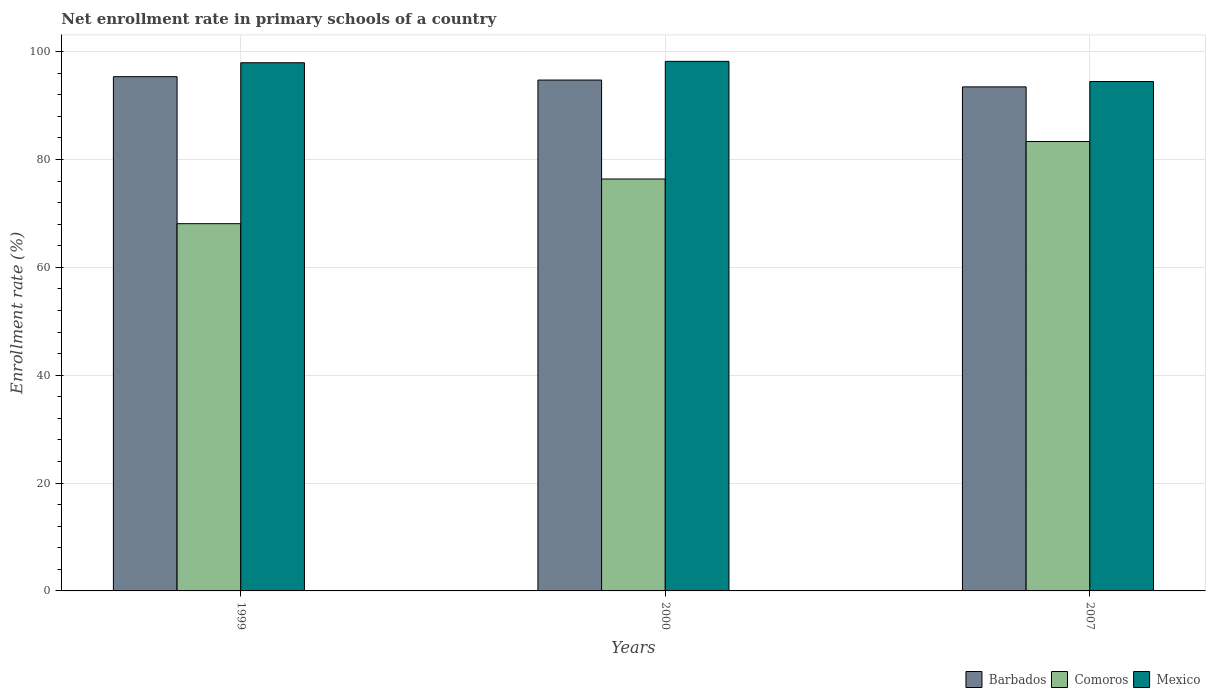How many bars are there on the 1st tick from the left?
Ensure brevity in your answer.  3. How many bars are there on the 3rd tick from the right?
Offer a very short reply. 3. In how many cases, is the number of bars for a given year not equal to the number of legend labels?
Your answer should be very brief. 0. What is the enrollment rate in primary schools in Mexico in 2000?
Ensure brevity in your answer.  98.2. Across all years, what is the maximum enrollment rate in primary schools in Mexico?
Keep it short and to the point. 98.2. Across all years, what is the minimum enrollment rate in primary schools in Barbados?
Your answer should be very brief. 93.47. What is the total enrollment rate in primary schools in Comoros in the graph?
Provide a succinct answer. 227.81. What is the difference between the enrollment rate in primary schools in Mexico in 1999 and that in 2007?
Provide a short and direct response. 3.48. What is the difference between the enrollment rate in primary schools in Comoros in 2007 and the enrollment rate in primary schools in Barbados in 1999?
Offer a terse response. -12.03. What is the average enrollment rate in primary schools in Barbados per year?
Keep it short and to the point. 94.52. In the year 2000, what is the difference between the enrollment rate in primary schools in Barbados and enrollment rate in primary schools in Mexico?
Provide a short and direct response. -3.47. What is the ratio of the enrollment rate in primary schools in Mexico in 1999 to that in 2007?
Your answer should be very brief. 1.04. Is the enrollment rate in primary schools in Barbados in 1999 less than that in 2007?
Your response must be concise. No. Is the difference between the enrollment rate in primary schools in Barbados in 2000 and 2007 greater than the difference between the enrollment rate in primary schools in Mexico in 2000 and 2007?
Provide a succinct answer. No. What is the difference between the highest and the second highest enrollment rate in primary schools in Mexico?
Keep it short and to the point. 0.26. What is the difference between the highest and the lowest enrollment rate in primary schools in Mexico?
Your response must be concise. 3.74. In how many years, is the enrollment rate in primary schools in Comoros greater than the average enrollment rate in primary schools in Comoros taken over all years?
Make the answer very short. 2. Is the sum of the enrollment rate in primary schools in Comoros in 1999 and 2000 greater than the maximum enrollment rate in primary schools in Barbados across all years?
Ensure brevity in your answer.  Yes. What does the 3rd bar from the right in 2000 represents?
Offer a terse response. Barbados. How many bars are there?
Offer a very short reply. 9. Are all the bars in the graph horizontal?
Provide a short and direct response. No. Does the graph contain any zero values?
Offer a terse response. No. How many legend labels are there?
Your answer should be very brief. 3. How are the legend labels stacked?
Provide a succinct answer. Horizontal. What is the title of the graph?
Make the answer very short. Net enrollment rate in primary schools of a country. What is the label or title of the X-axis?
Provide a short and direct response. Years. What is the label or title of the Y-axis?
Provide a succinct answer. Enrollment rate (%). What is the Enrollment rate (%) in Barbados in 1999?
Give a very brief answer. 95.36. What is the Enrollment rate (%) in Comoros in 1999?
Ensure brevity in your answer.  68.1. What is the Enrollment rate (%) in Mexico in 1999?
Your answer should be compact. 97.94. What is the Enrollment rate (%) in Barbados in 2000?
Offer a very short reply. 94.73. What is the Enrollment rate (%) in Comoros in 2000?
Provide a short and direct response. 76.38. What is the Enrollment rate (%) of Mexico in 2000?
Provide a succinct answer. 98.2. What is the Enrollment rate (%) of Barbados in 2007?
Ensure brevity in your answer.  93.47. What is the Enrollment rate (%) in Comoros in 2007?
Your answer should be very brief. 83.33. What is the Enrollment rate (%) of Mexico in 2007?
Provide a short and direct response. 94.46. Across all years, what is the maximum Enrollment rate (%) of Barbados?
Ensure brevity in your answer.  95.36. Across all years, what is the maximum Enrollment rate (%) in Comoros?
Keep it short and to the point. 83.33. Across all years, what is the maximum Enrollment rate (%) of Mexico?
Your response must be concise. 98.2. Across all years, what is the minimum Enrollment rate (%) of Barbados?
Offer a terse response. 93.47. Across all years, what is the minimum Enrollment rate (%) of Comoros?
Your answer should be compact. 68.1. Across all years, what is the minimum Enrollment rate (%) in Mexico?
Keep it short and to the point. 94.46. What is the total Enrollment rate (%) in Barbados in the graph?
Your answer should be compact. 283.56. What is the total Enrollment rate (%) in Comoros in the graph?
Ensure brevity in your answer.  227.81. What is the total Enrollment rate (%) in Mexico in the graph?
Give a very brief answer. 290.6. What is the difference between the Enrollment rate (%) in Barbados in 1999 and that in 2000?
Provide a succinct answer. 0.63. What is the difference between the Enrollment rate (%) in Comoros in 1999 and that in 2000?
Your answer should be compact. -8.28. What is the difference between the Enrollment rate (%) of Mexico in 1999 and that in 2000?
Offer a very short reply. -0.26. What is the difference between the Enrollment rate (%) of Barbados in 1999 and that in 2007?
Offer a very short reply. 1.89. What is the difference between the Enrollment rate (%) in Comoros in 1999 and that in 2007?
Provide a short and direct response. -15.23. What is the difference between the Enrollment rate (%) in Mexico in 1999 and that in 2007?
Ensure brevity in your answer.  3.48. What is the difference between the Enrollment rate (%) in Barbados in 2000 and that in 2007?
Offer a very short reply. 1.27. What is the difference between the Enrollment rate (%) of Comoros in 2000 and that in 2007?
Your answer should be very brief. -6.95. What is the difference between the Enrollment rate (%) of Mexico in 2000 and that in 2007?
Your answer should be very brief. 3.74. What is the difference between the Enrollment rate (%) of Barbados in 1999 and the Enrollment rate (%) of Comoros in 2000?
Offer a terse response. 18.98. What is the difference between the Enrollment rate (%) of Barbados in 1999 and the Enrollment rate (%) of Mexico in 2000?
Offer a very short reply. -2.84. What is the difference between the Enrollment rate (%) of Comoros in 1999 and the Enrollment rate (%) of Mexico in 2000?
Your answer should be compact. -30.1. What is the difference between the Enrollment rate (%) in Barbados in 1999 and the Enrollment rate (%) in Comoros in 2007?
Your answer should be very brief. 12.03. What is the difference between the Enrollment rate (%) of Barbados in 1999 and the Enrollment rate (%) of Mexico in 2007?
Provide a succinct answer. 0.9. What is the difference between the Enrollment rate (%) of Comoros in 1999 and the Enrollment rate (%) of Mexico in 2007?
Make the answer very short. -26.36. What is the difference between the Enrollment rate (%) of Barbados in 2000 and the Enrollment rate (%) of Comoros in 2007?
Offer a terse response. 11.4. What is the difference between the Enrollment rate (%) in Barbados in 2000 and the Enrollment rate (%) in Mexico in 2007?
Ensure brevity in your answer.  0.27. What is the difference between the Enrollment rate (%) in Comoros in 2000 and the Enrollment rate (%) in Mexico in 2007?
Make the answer very short. -18.08. What is the average Enrollment rate (%) of Barbados per year?
Offer a very short reply. 94.52. What is the average Enrollment rate (%) of Comoros per year?
Offer a very short reply. 75.94. What is the average Enrollment rate (%) of Mexico per year?
Keep it short and to the point. 96.87. In the year 1999, what is the difference between the Enrollment rate (%) in Barbados and Enrollment rate (%) in Comoros?
Offer a terse response. 27.26. In the year 1999, what is the difference between the Enrollment rate (%) in Barbados and Enrollment rate (%) in Mexico?
Your response must be concise. -2.58. In the year 1999, what is the difference between the Enrollment rate (%) in Comoros and Enrollment rate (%) in Mexico?
Keep it short and to the point. -29.84. In the year 2000, what is the difference between the Enrollment rate (%) in Barbados and Enrollment rate (%) in Comoros?
Provide a short and direct response. 18.35. In the year 2000, what is the difference between the Enrollment rate (%) in Barbados and Enrollment rate (%) in Mexico?
Keep it short and to the point. -3.47. In the year 2000, what is the difference between the Enrollment rate (%) in Comoros and Enrollment rate (%) in Mexico?
Offer a very short reply. -21.82. In the year 2007, what is the difference between the Enrollment rate (%) in Barbados and Enrollment rate (%) in Comoros?
Give a very brief answer. 10.13. In the year 2007, what is the difference between the Enrollment rate (%) in Barbados and Enrollment rate (%) in Mexico?
Provide a succinct answer. -0.99. In the year 2007, what is the difference between the Enrollment rate (%) of Comoros and Enrollment rate (%) of Mexico?
Your answer should be very brief. -11.13. What is the ratio of the Enrollment rate (%) of Barbados in 1999 to that in 2000?
Offer a terse response. 1.01. What is the ratio of the Enrollment rate (%) in Comoros in 1999 to that in 2000?
Ensure brevity in your answer.  0.89. What is the ratio of the Enrollment rate (%) of Mexico in 1999 to that in 2000?
Provide a short and direct response. 1. What is the ratio of the Enrollment rate (%) of Barbados in 1999 to that in 2007?
Ensure brevity in your answer.  1.02. What is the ratio of the Enrollment rate (%) in Comoros in 1999 to that in 2007?
Offer a very short reply. 0.82. What is the ratio of the Enrollment rate (%) of Mexico in 1999 to that in 2007?
Your response must be concise. 1.04. What is the ratio of the Enrollment rate (%) in Barbados in 2000 to that in 2007?
Provide a succinct answer. 1.01. What is the ratio of the Enrollment rate (%) in Comoros in 2000 to that in 2007?
Give a very brief answer. 0.92. What is the ratio of the Enrollment rate (%) of Mexico in 2000 to that in 2007?
Provide a succinct answer. 1.04. What is the difference between the highest and the second highest Enrollment rate (%) of Barbados?
Make the answer very short. 0.63. What is the difference between the highest and the second highest Enrollment rate (%) in Comoros?
Make the answer very short. 6.95. What is the difference between the highest and the second highest Enrollment rate (%) of Mexico?
Your answer should be compact. 0.26. What is the difference between the highest and the lowest Enrollment rate (%) of Barbados?
Provide a short and direct response. 1.89. What is the difference between the highest and the lowest Enrollment rate (%) in Comoros?
Your answer should be compact. 15.23. What is the difference between the highest and the lowest Enrollment rate (%) of Mexico?
Keep it short and to the point. 3.74. 